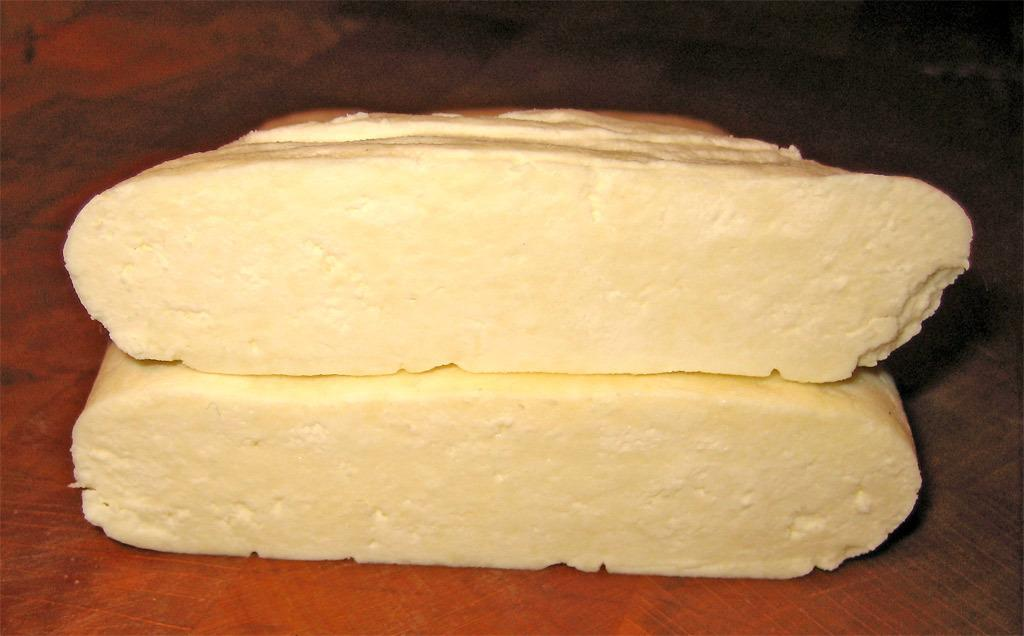What type of food is visible in the image? There are two bread slices in the image. Where are the bread slices located? The bread slices are on a table. What type of education is being taught in the image? There is no indication of any educational activity in the image; it features two bread slices on a table. What type of blade is being used to cut the bread in the image? There is no blade visible in the image, nor is there any indication that the bread is being cut. 